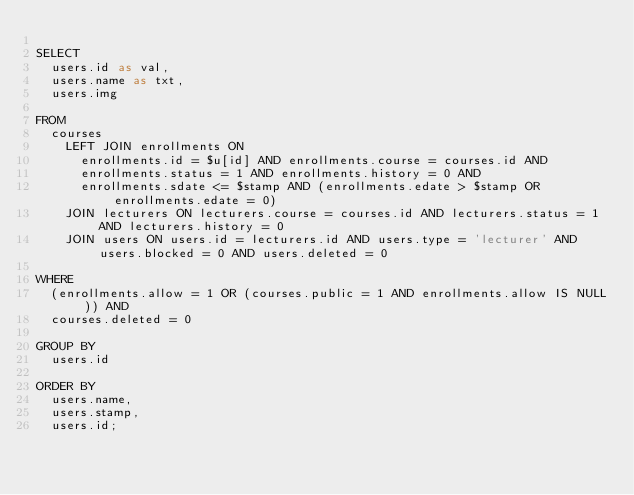<code> <loc_0><loc_0><loc_500><loc_500><_SQL_>
SELECT
  users.id as val,
  users.name as txt,
  users.img

FROM
  courses
    LEFT JOIN enrollments ON
      enrollments.id = $u[id] AND enrollments.course = courses.id AND
      enrollments.status = 1 AND enrollments.history = 0 AND
      enrollments.sdate <= $stamp AND (enrollments.edate > $stamp OR enrollments.edate = 0)
    JOIN lecturers ON lecturers.course = courses.id AND lecturers.status = 1 AND lecturers.history = 0
    JOIN users ON users.id = lecturers.id AND users.type = 'lecturer' AND users.blocked = 0 AND users.deleted = 0

WHERE
  (enrollments.allow = 1 OR (courses.public = 1 AND enrollments.allow IS NULL)) AND
  courses.deleted = 0

GROUP BY
  users.id
  
ORDER BY
  users.name,
  users.stamp,
  users.id;</code> 